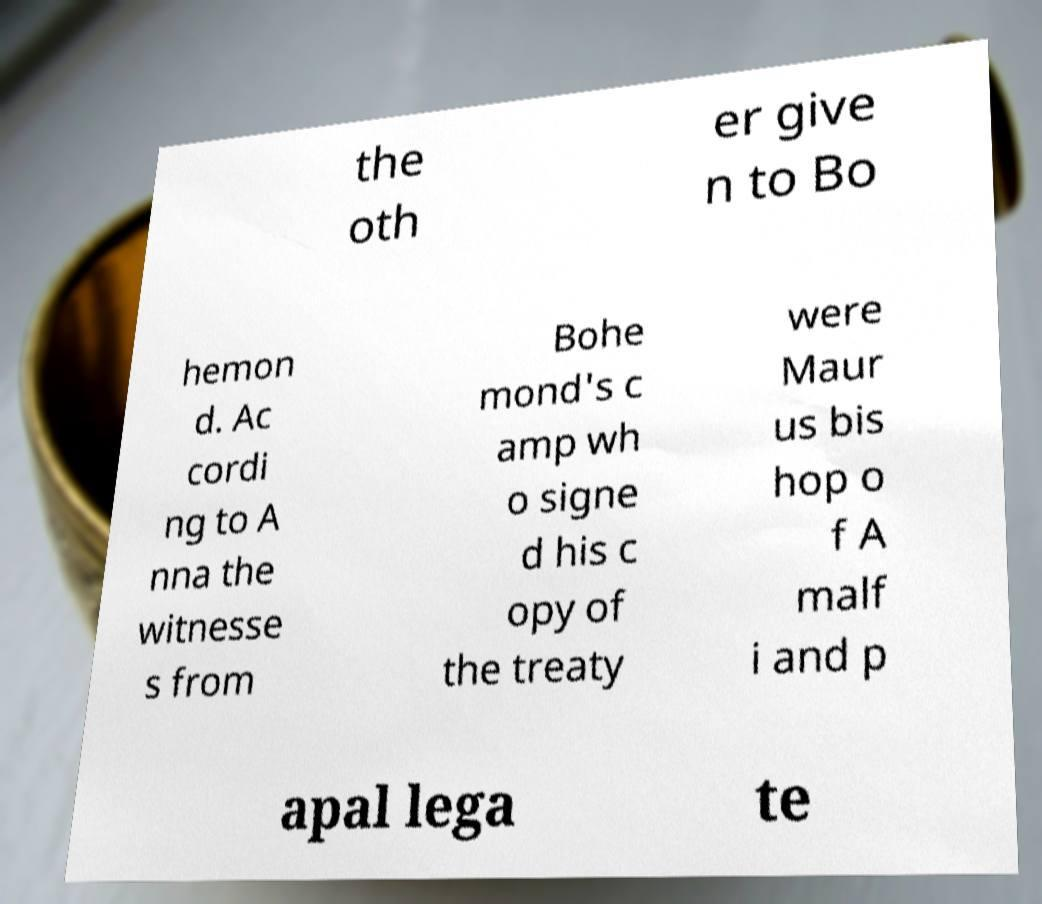Can you read and provide the text displayed in the image?This photo seems to have some interesting text. Can you extract and type it out for me? the oth er give n to Bo hemon d. Ac cordi ng to A nna the witnesse s from Bohe mond's c amp wh o signe d his c opy of the treaty were Maur us bis hop o f A malf i and p apal lega te 